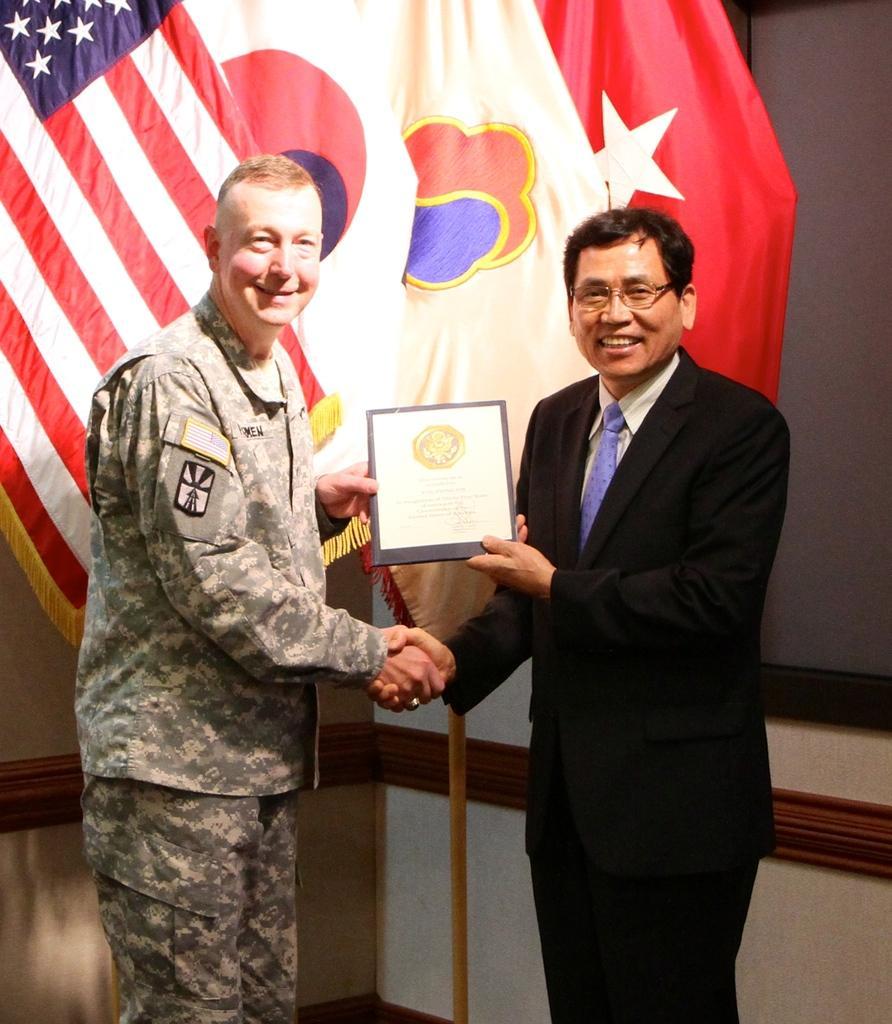Please provide a concise description of this image. In this image there are two men standing shaking their hands and holding a certificate in their hands, in the background there are flags. 